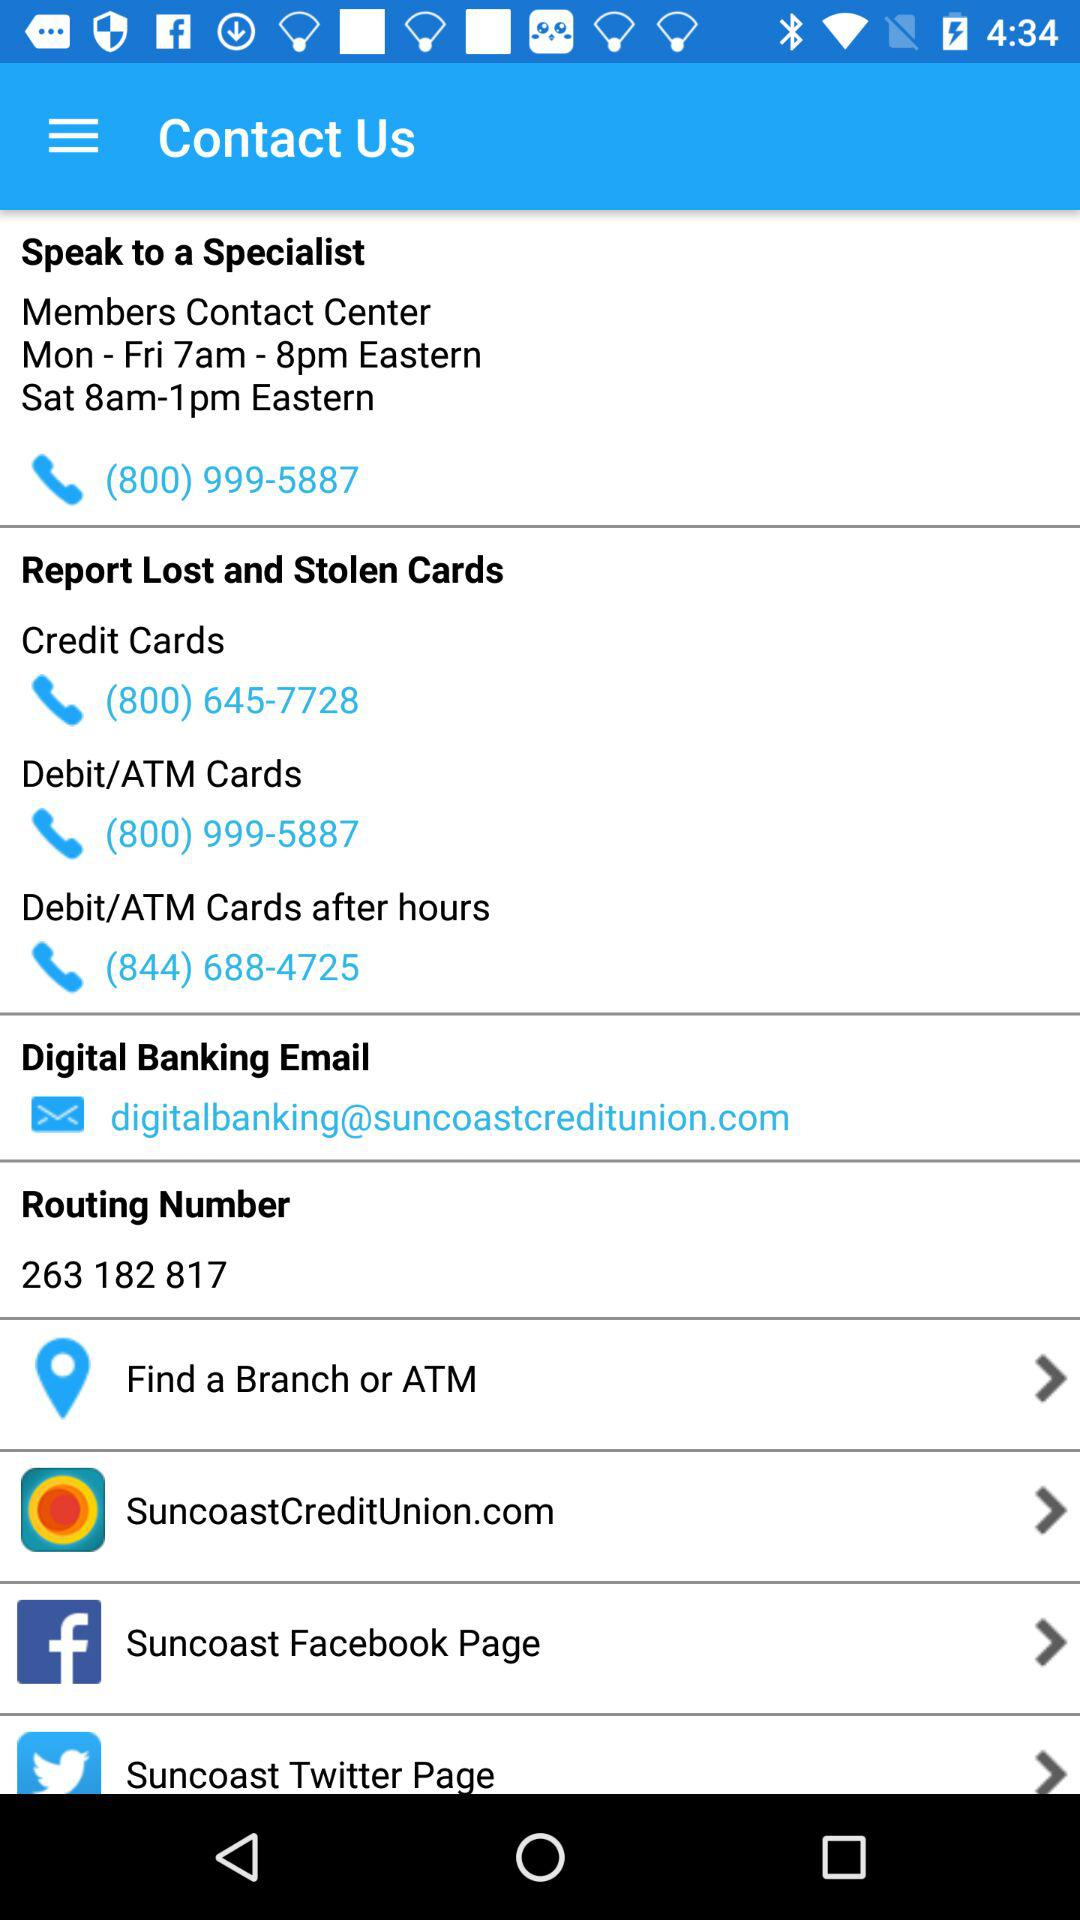What is the phone number available to report lost and stolen debit /ATM cards? The phone number available to report lost and stolen debit /ATM cards is (800) 999-5887. 